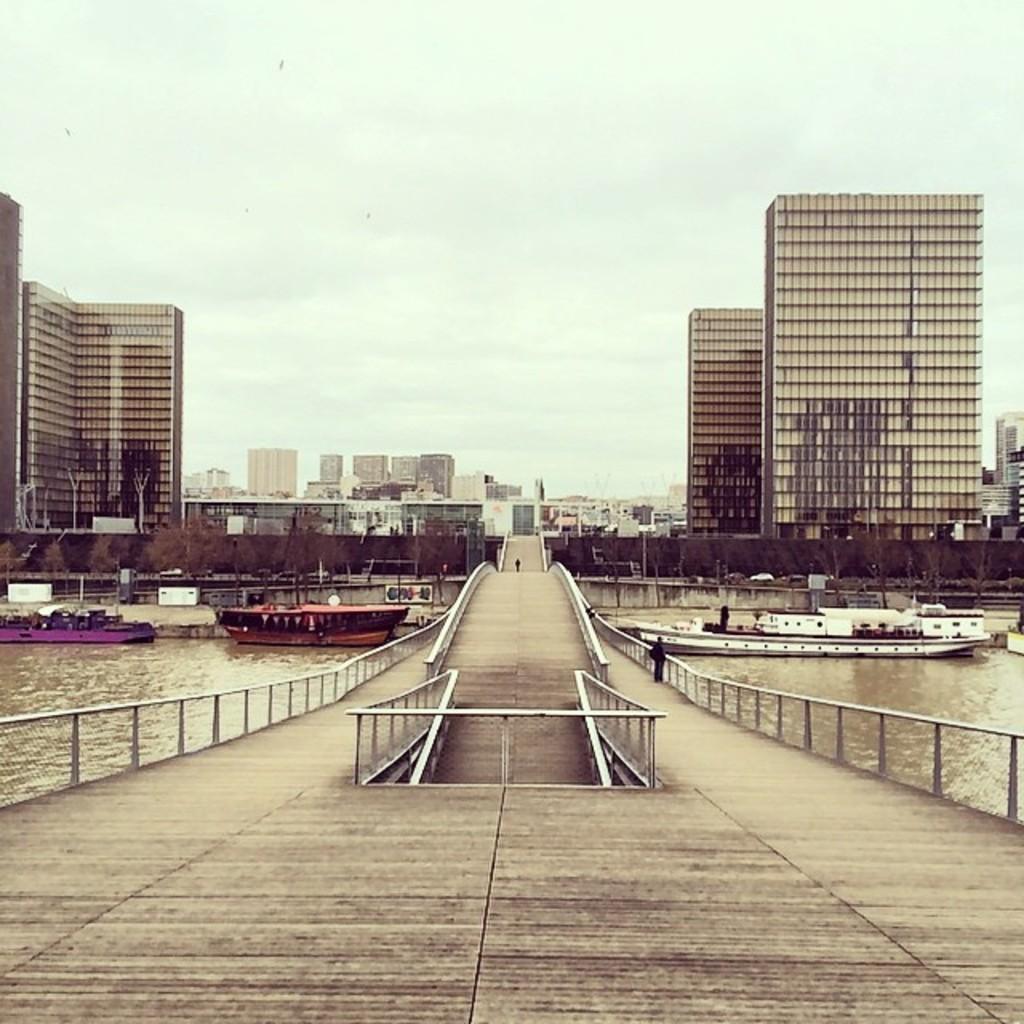In one or two sentences, can you explain what this image depicts? In this image we can see some boats on the water and a bridge with fence. On the backside we can see some buildings and the sky which looks cloudy. 